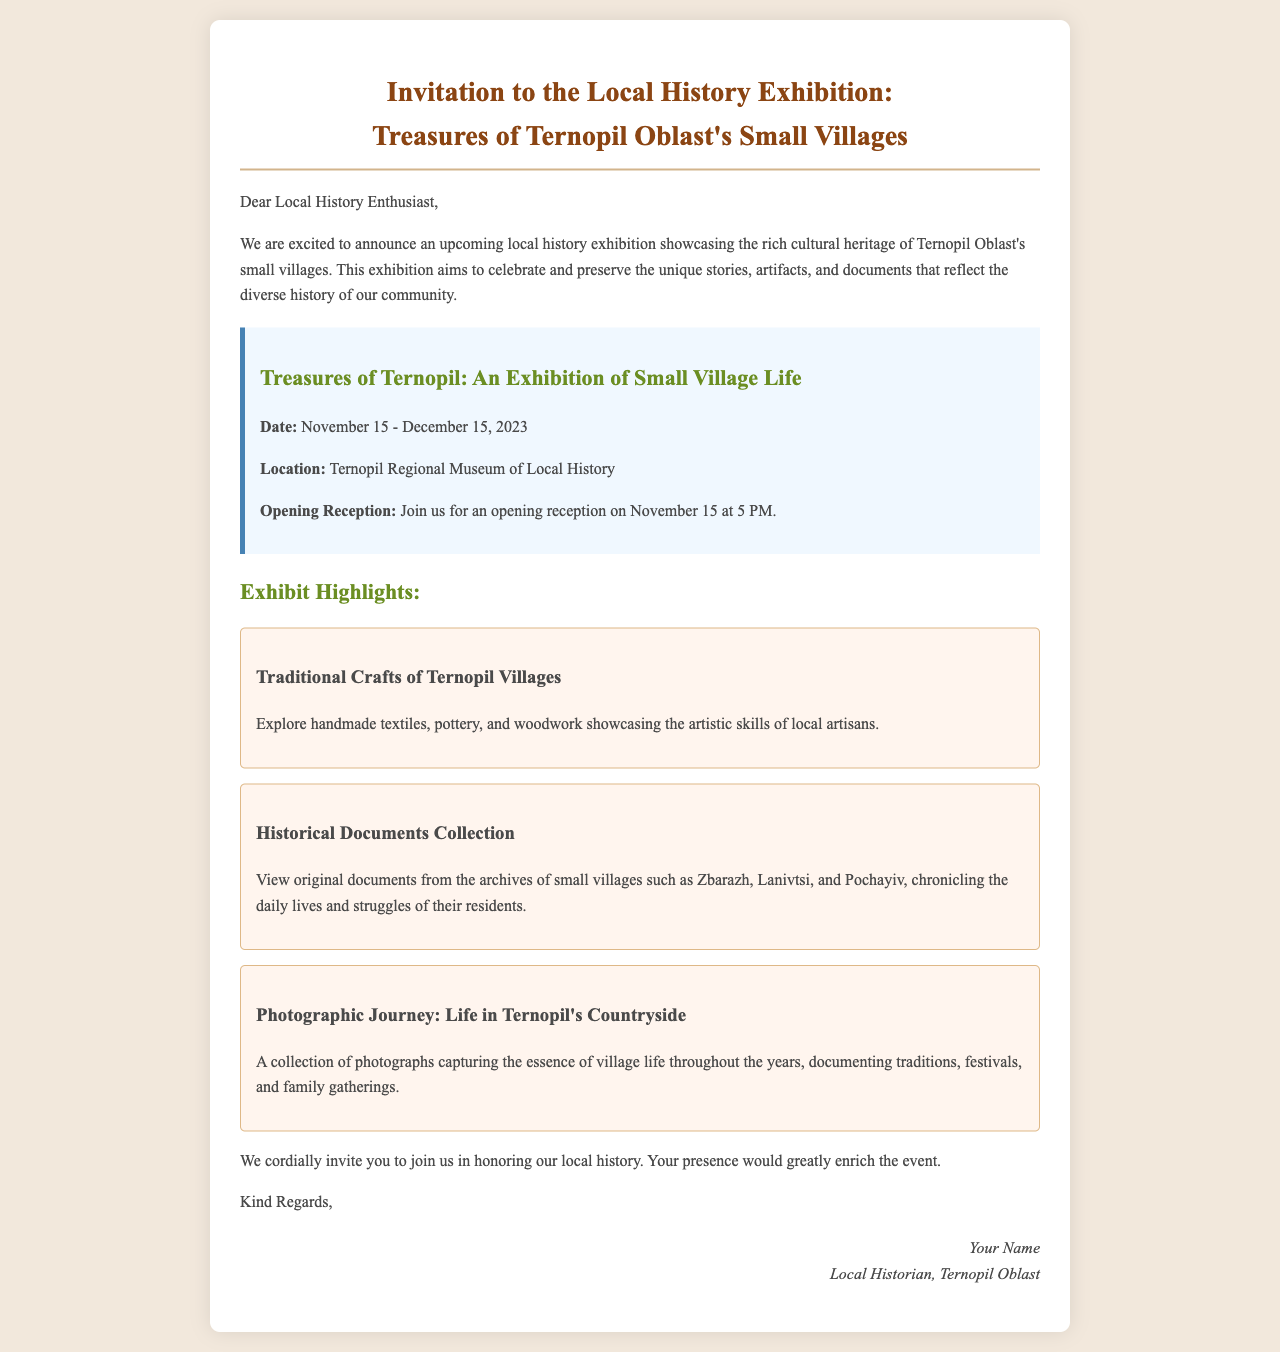What is the title of the exhibition? The title of the exhibition is prominently displayed in the document: "Treasures of Ternopil Oblast's Small Villages".
Answer: Treasures of Ternopil Oblast's Small Villages When does the exhibition start? The date of the exhibition is clearly mentioned in the document as starting on November 15, 2023.
Answer: November 15, 2023 Where is the exhibition being held? The location of the exhibition is specified in the document as the Ternopil Regional Museum of Local History.
Answer: Ternopil Regional Museum of Local History What is highlighted in the exhibition regarding traditional crafts? The document features a section on traditional crafts which showcases "handmade textiles, pottery, and woodwork."
Answer: handmade textiles, pottery, and woodwork What is the date and time of the opening reception? The opening reception details are included in the document, stating that it is on November 15 at 5 PM.
Answer: November 15 at 5 PM Which villages are mentioned in the Historical Documents Collection? The document lists specific villages included in the Historical Documents Collection, which are Zbarazh, Lanivtsi, and Pochayiv.
Answer: Zbarazh, Lanivtsi, and Pochayiv What type of photographic content is featured in the exhibit? The document describes the photographic content as capturing "the essence of village life throughout the years."
Answer: the essence of village life throughout the years Who is signing off the invitation? The signature in the document indicates the person signing off as "Your Name, Local Historian, Ternopil Oblast."
Answer: Your Name, Local Historian, Ternopil Oblast 